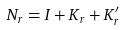<formula> <loc_0><loc_0><loc_500><loc_500>N _ { r } = I + K _ { r } + K ^ { \prime } _ { r }</formula> 